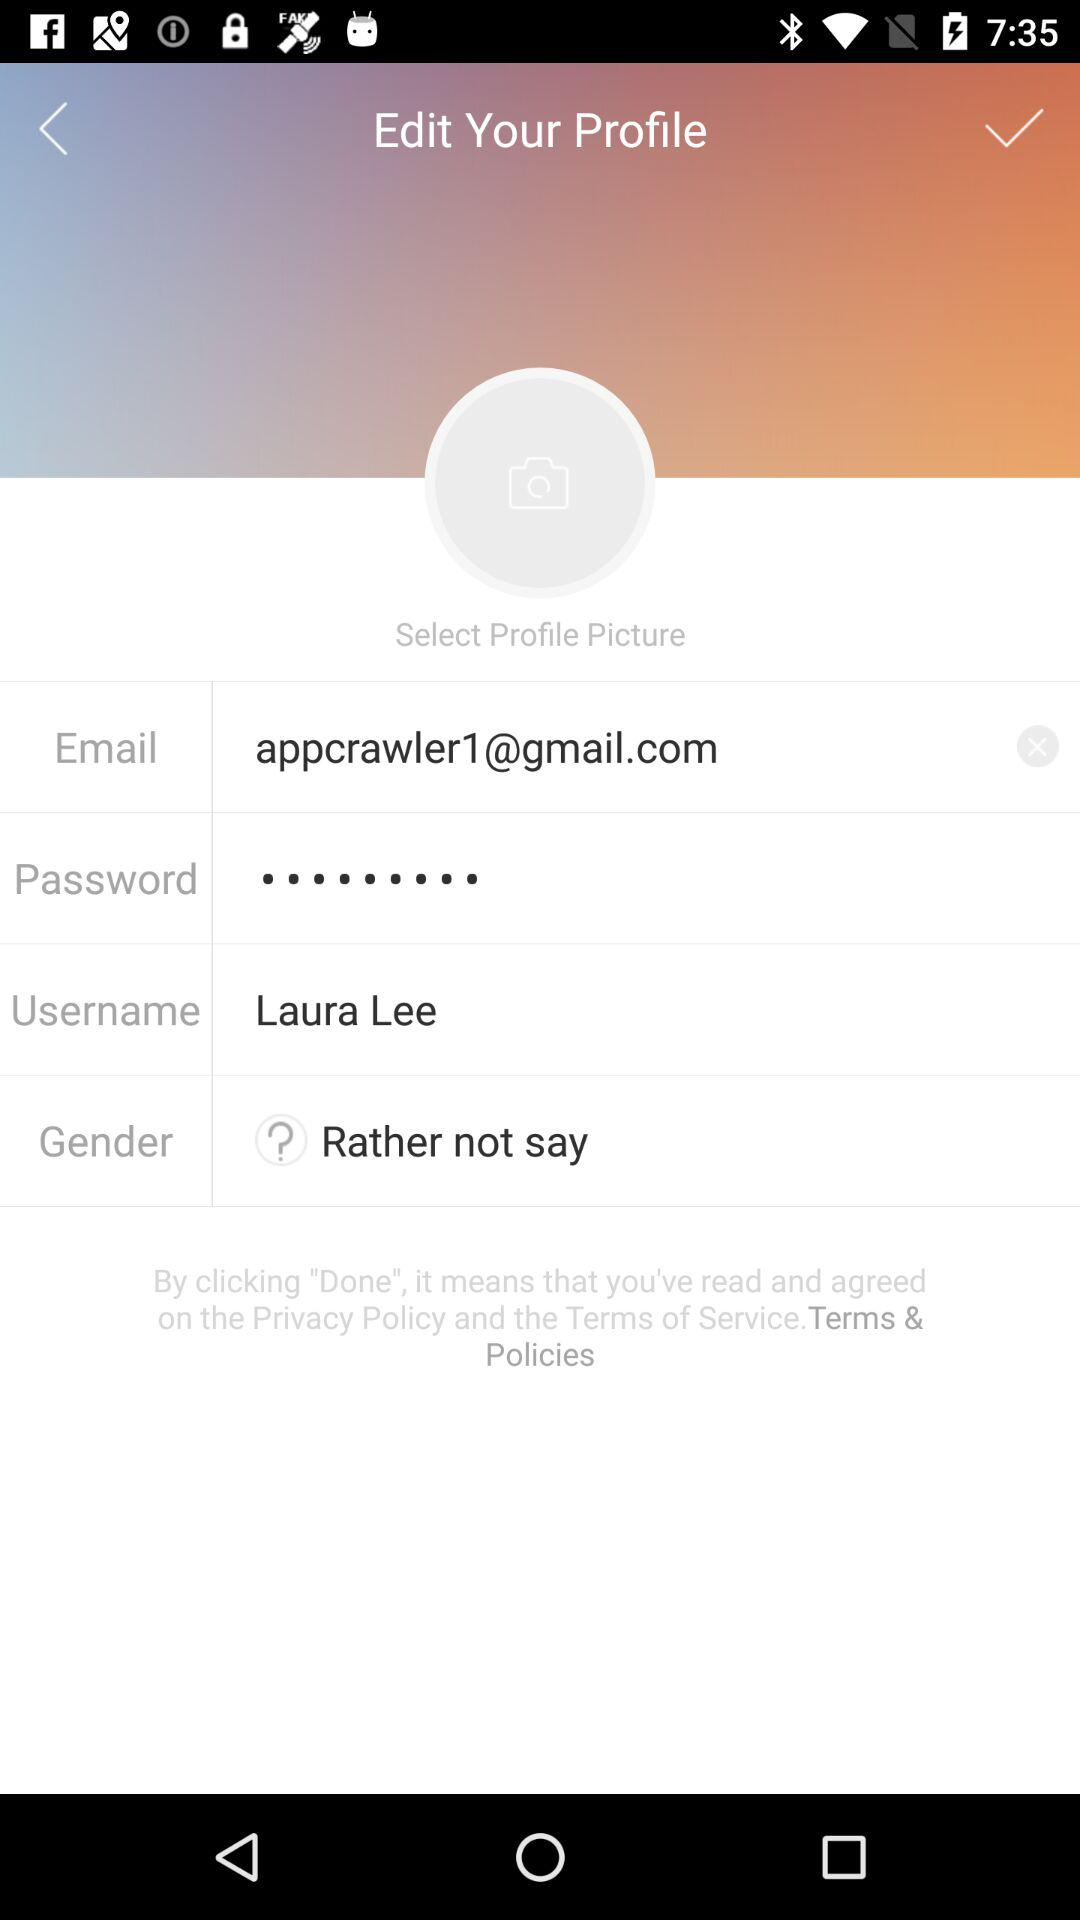What is the email address? The email address is "appcrawler1@gmail.com". 